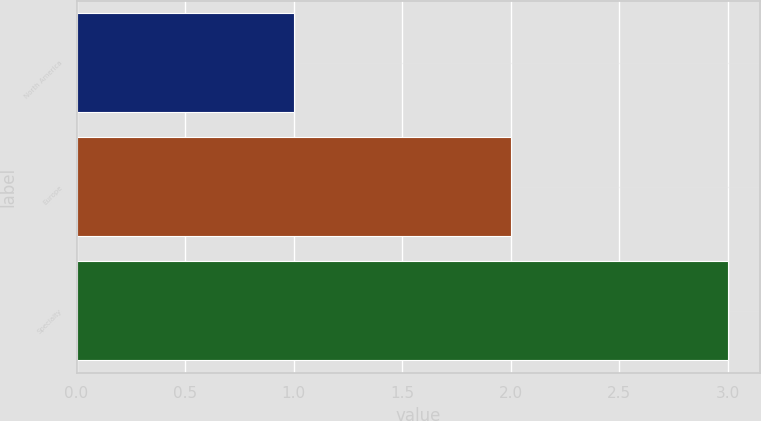Convert chart to OTSL. <chart><loc_0><loc_0><loc_500><loc_500><bar_chart><fcel>North America<fcel>Europe<fcel>Specialty<nl><fcel>1<fcel>2<fcel>3<nl></chart> 